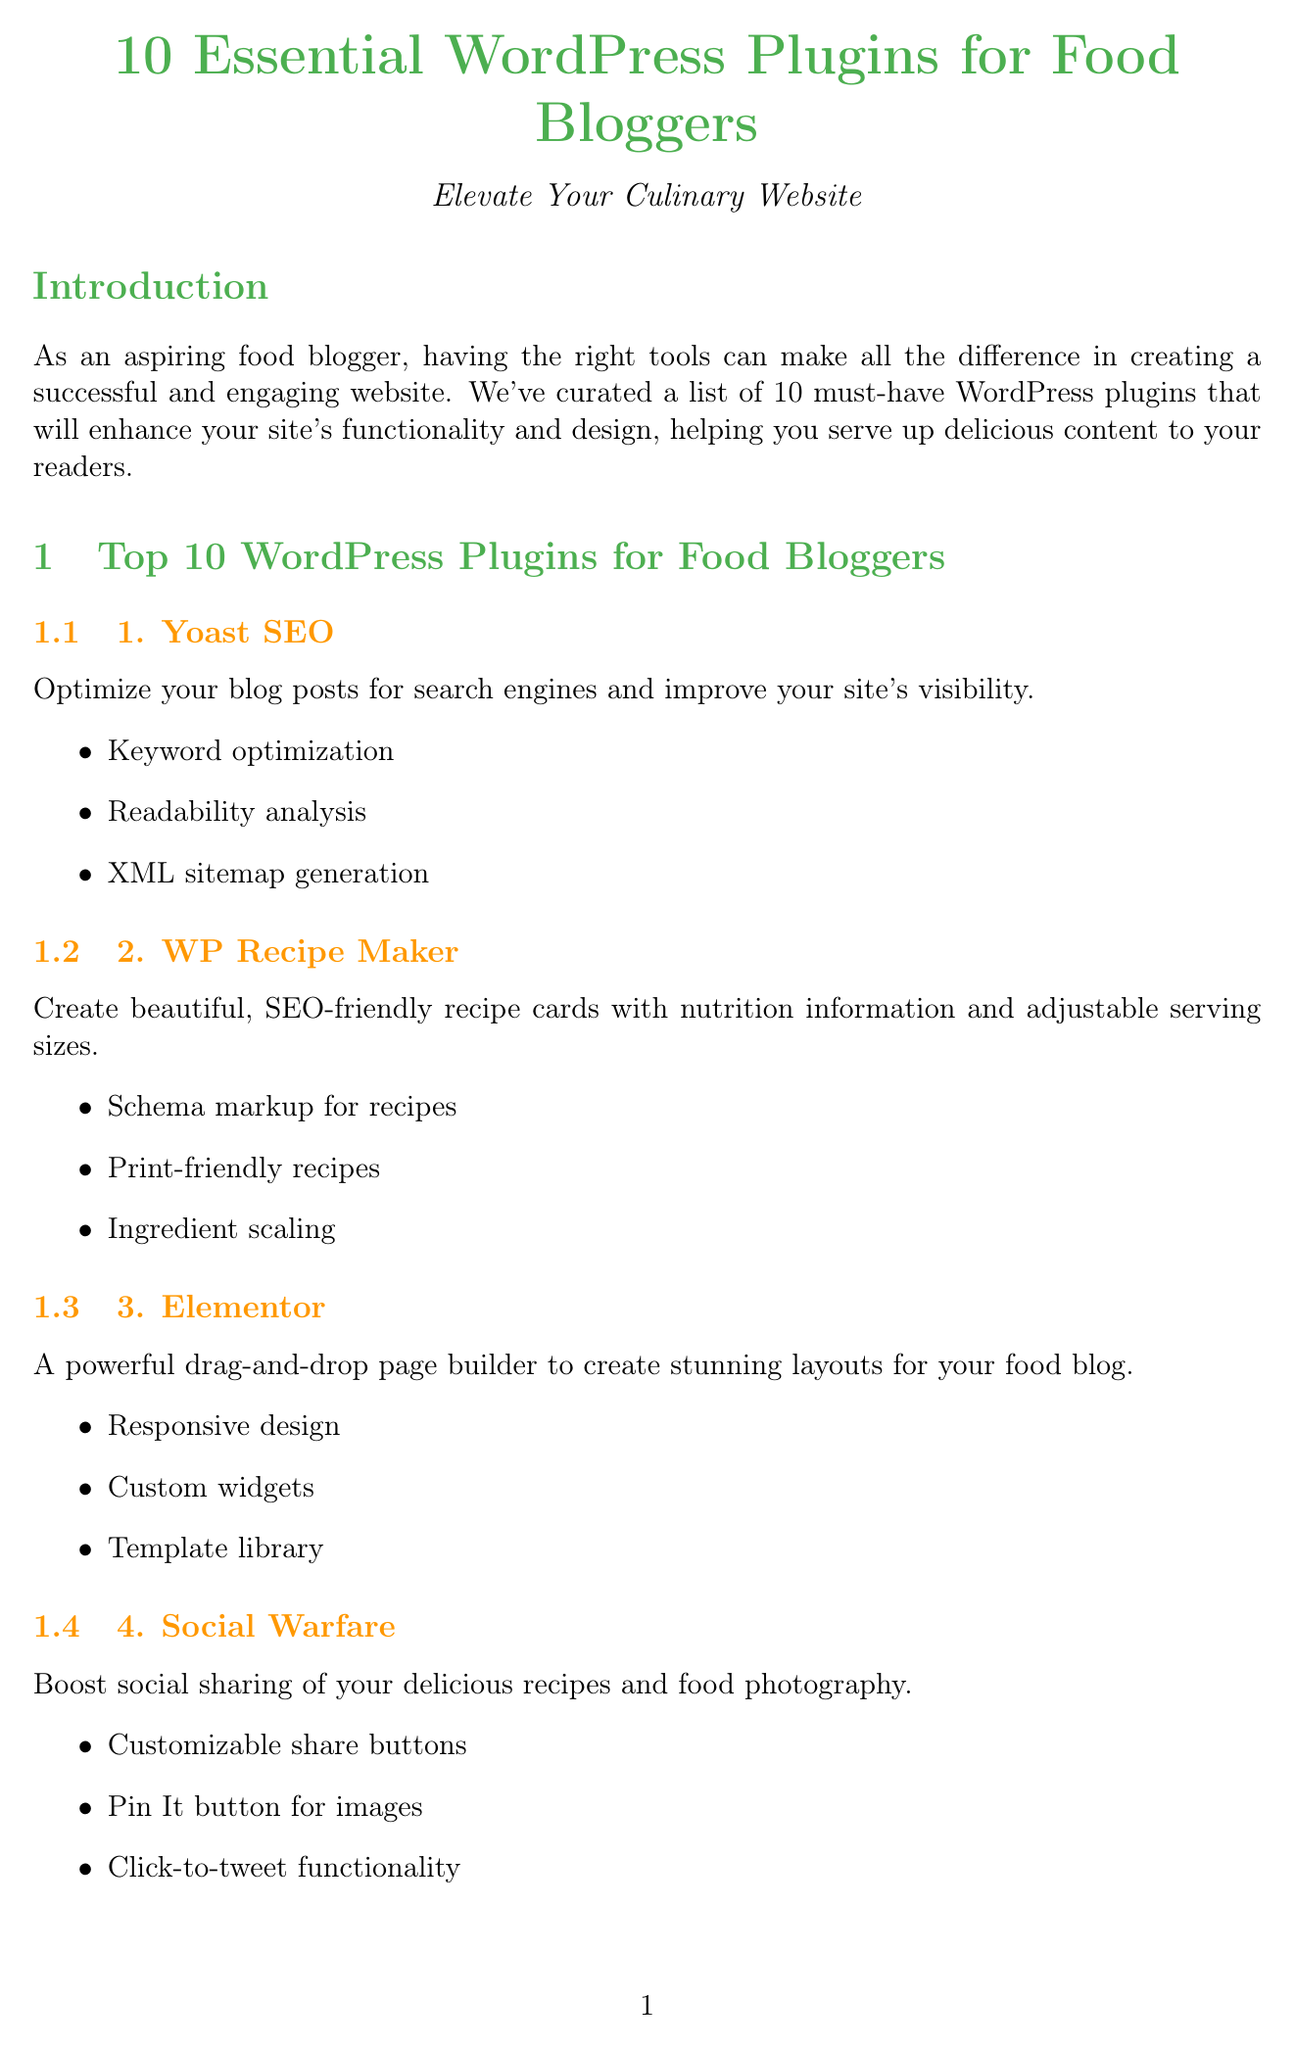What is the title of the newsletter? The title of the newsletter is found at the beginning of the document, stating the main focus for food bloggers.
Answer: 10 Essential WordPress Plugins for Food Bloggers: Elevate Your Culinary Website How many plugins are listed in the newsletter? The number of plugins can be counted from the list provided in the document, which shows all must-have plugins.
Answer: 10 Which plugin offers a drag-and-drop page builder? The specific plugin that provides the drag-and-drop functionality is mentioned along with its description in the document.
Answer: Elementor What feature does WP Recipe Maker provide? The features of WP Recipe Maker are outlined in the document, highlighting its main capabilities for food bloggers.
Answer: SEO-friendly recipe cards What is the premium price for WP Rocket? The premium version pricing for WP Rocket is specified in the comparison chart included in the newsletter.
Answer: $49/year Which plugin is used for optimizing food photography? The description section notes which plugin is specifically intended for image optimization in the context of food blogging.
Answer: ShortPixel Image Optimizer Who provided a testimonial for Social Warfare? The name is mentioned in the user testimonials section where various bloggers share their experiences with the plugins.
Answer: Emma Rodriguez What type of support does Elementor provide for its premium users? The support options for Elementor can be found in the comparison chart, detailing the type of assistance offered.
Answer: 24/7 Live Chat How often is WP Recipe Maker updated? The update frequency for WP Recipe Maker is indicated in the comparison chart, showing the regularity of updates.
Answer: Frequent 